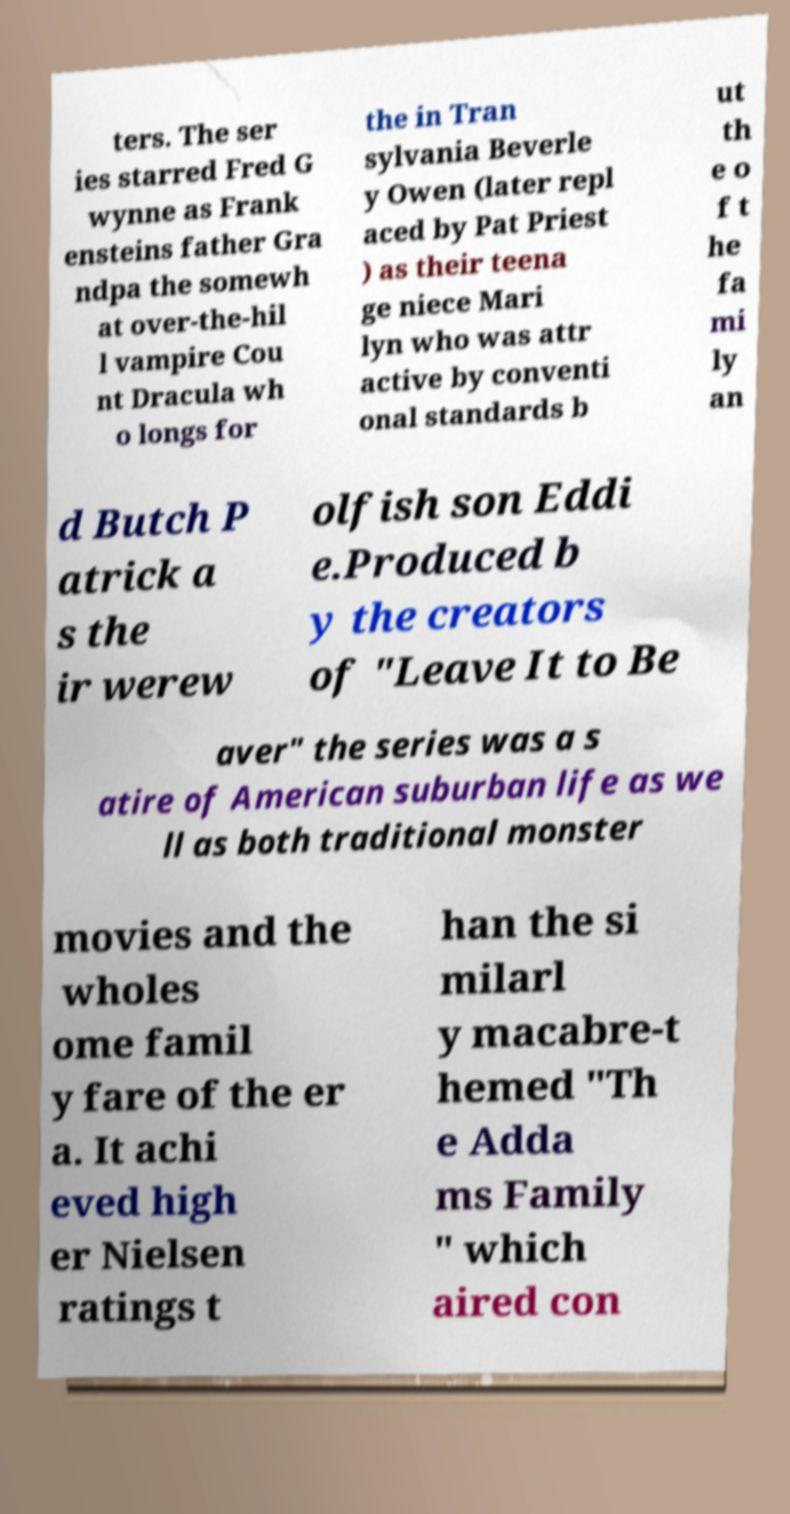I need the written content from this picture converted into text. Can you do that? ters. The ser ies starred Fred G wynne as Frank ensteins father Gra ndpa the somewh at over-the-hil l vampire Cou nt Dracula wh o longs for the in Tran sylvania Beverle y Owen (later repl aced by Pat Priest ) as their teena ge niece Mari lyn who was attr active by conventi onal standards b ut th e o f t he fa mi ly an d Butch P atrick a s the ir werew olfish son Eddi e.Produced b y the creators of "Leave It to Be aver" the series was a s atire of American suburban life as we ll as both traditional monster movies and the wholes ome famil y fare of the er a. It achi eved high er Nielsen ratings t han the si milarl y macabre-t hemed "Th e Adda ms Family " which aired con 